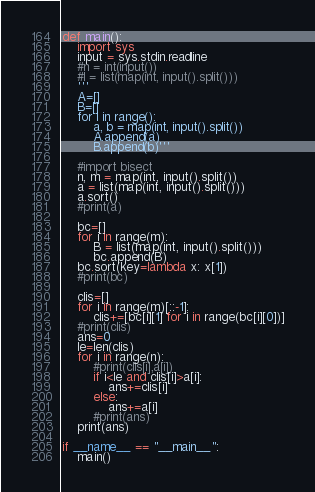Convert code to text. <code><loc_0><loc_0><loc_500><loc_500><_Python_>def main():
    import sys
    input = sys.stdin.readline
    #n = int(input())
    #l = list(map(int, input().split()))
    '''
    A=[]
    B=[]
    for i in range():
        a, b = map(int, input().split())
        A.append(a)
        B.append(b)'''

    #import bisect
    n, m = map(int, input().split())
    a = list(map(int, input().split()))
    a.sort()
    #print(a)

    bc=[]
    for i in range(m):
        B = list(map(int, input().split()))
        bc.append(B)
    bc.sort(key=lambda x: x[1])
    #print(bc)

    clis=[]
    for i in range(m)[::-1]:
        clis+=[bc[i][1] for i in range(bc[i][0])]
    #print(clis)
    ans=0
    le=len(clis)
    for i in range(n):
        #print(clis[i],a[i])
        if i<le and clis[i]>a[i]:
            ans+=clis[i]
        else:
            ans+=a[i]
        #print(ans)
    print(ans)

if __name__ == "__main__":
    main()</code> 